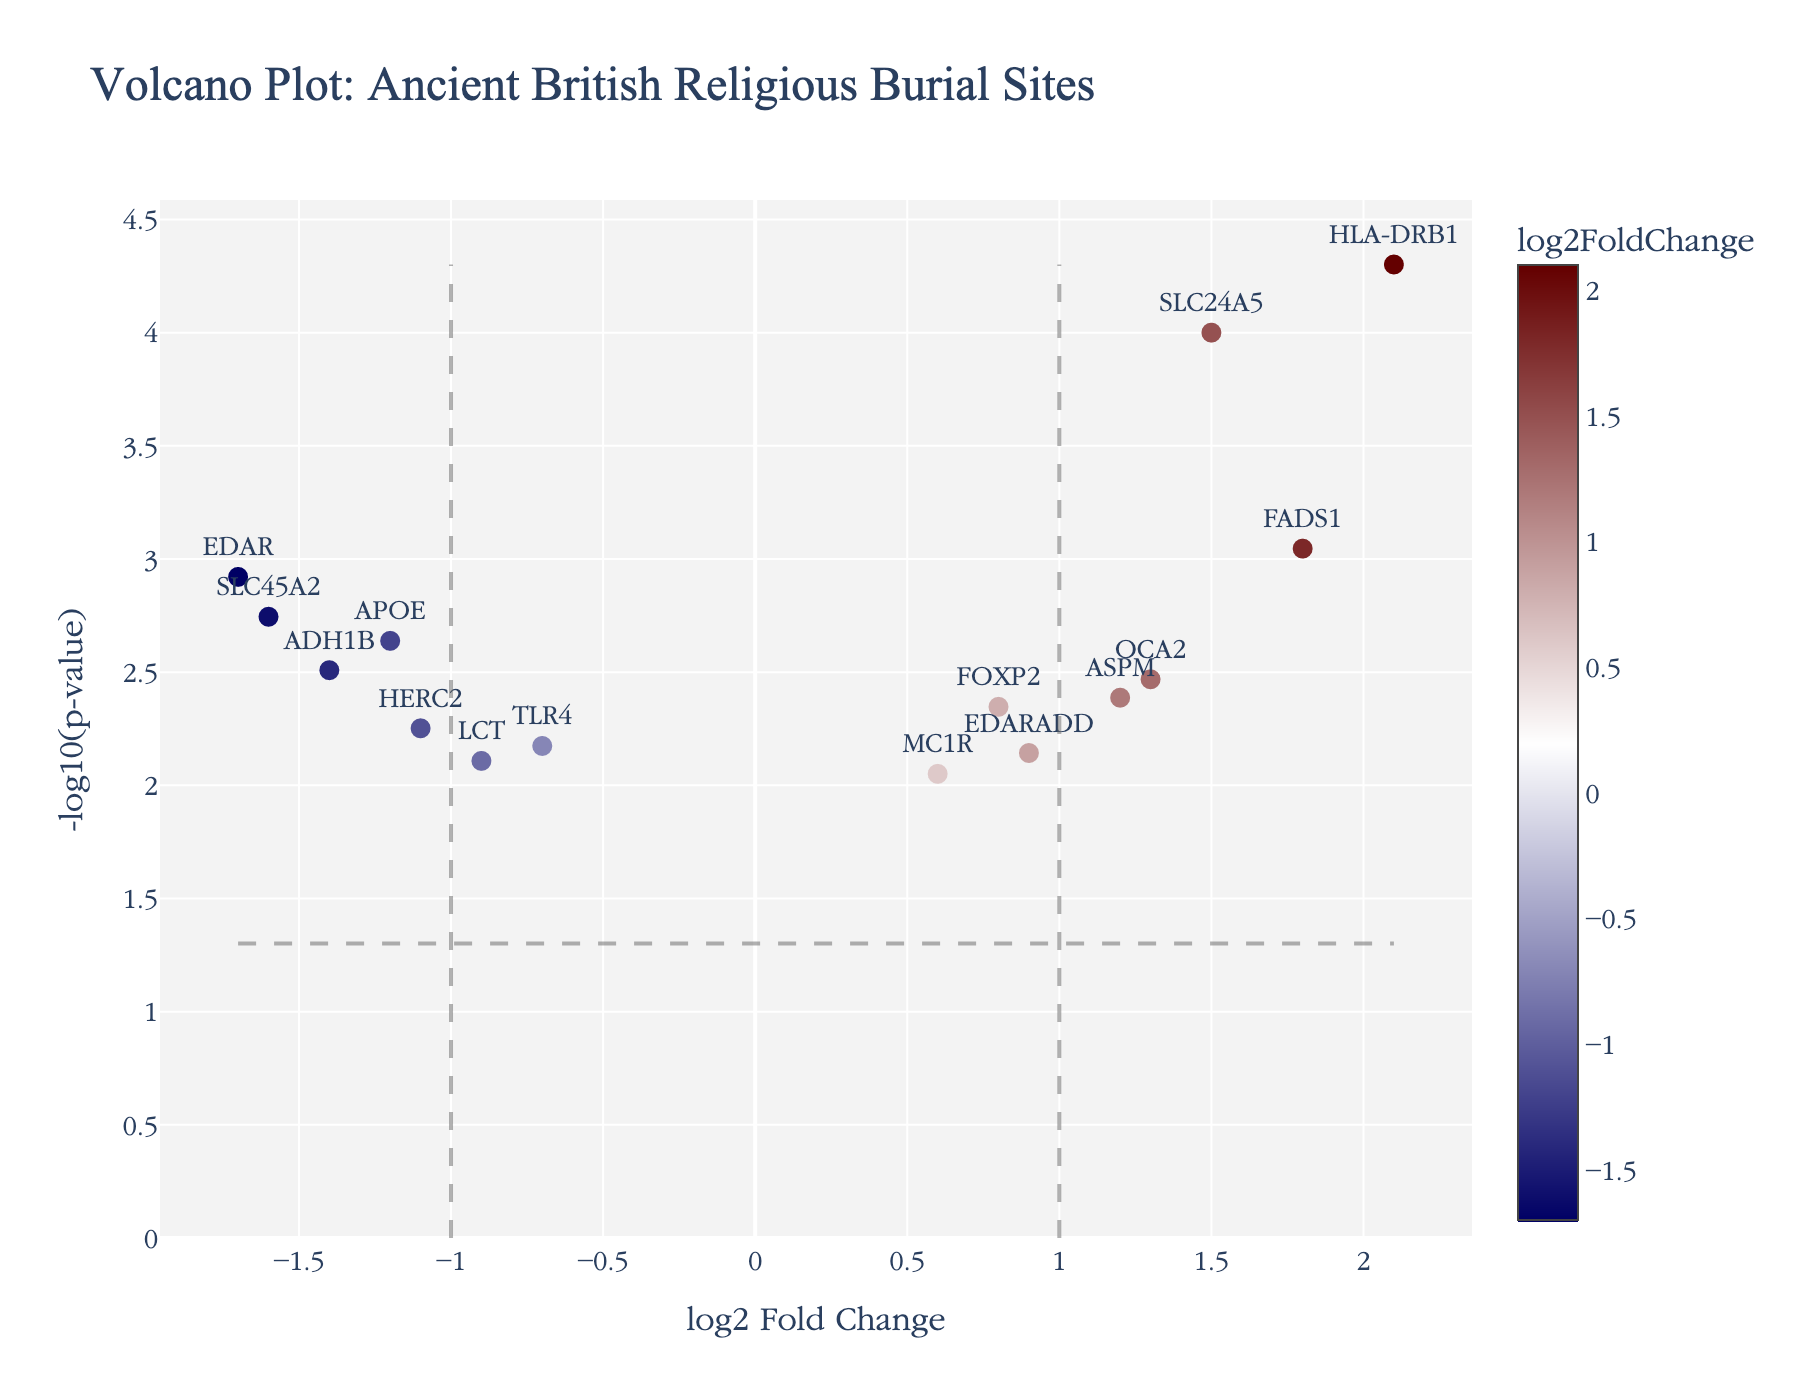What is the title of the volcano plot? The title is usually displayed at the top of the plot and gives an idea about what the plot represents. In this case, the title "Volcano Plot: Ancient British Religious Burial Sites" can be read directly from the plot.
Answer: Volcano Plot: Ancient British Religious Burial Sites Which gene has the highest log2 fold change? To determine the gene with the highest log2 fold change look for the point farthest to the right on the x-axis. In this plot, it is the gene HLA-DRB1 with a log2 fold change of 2.1.
Answer: HLA-DRB1 What is the significance threshold line set at for the p-value? The horizontal line on the plot represents the significance threshold, usually at -log10(0.05), which is about 1.3 on the y-axis.
Answer: -log10(0.05) Which genes are found above the significance threshold line? To answer this, look for genes placed above the horizontal threshold line at -log10(0.05). These genes include APOE, FOXP2, SLC24A5, HLA-DRB1, EDAR, OCA2, FADS1, ADH1B, SLC45A2, and ASPM.
Answer: APOE, FOXP2, SLC24A5, HLA-DRB1, EDAR, OCA2, FADS1, ADH1B, SLC45A2, ASPM Which gene has the lowest p-value and what is its log2 fold change? The gene with the lowest p-value will be the one positioned at the top of the plot. This gene is HLA-DRB1 with a log2 fold change of 2.1 and a p-value of 0.00005.
Answer: HLA-DRB1, log2 fold change is 2.1 Are there any genes with a log2 fold change less than -1 and significant p-value? Look for genes on the left of the vertical line at log2 fold change = -1 and which lie above the significance threshold line. These genes are APOE, EDAR, ADH1B, and SLC45A2.
Answer: APOE, EDAR, ADH1B, SLC45A2 Which genes have a log2 fold change greater than 1 and a p-value less than 0.001? This requires looking at genes to the right of the vertical line at log2 fold change = 1 and above the horizontal line denoting -log10(0.001). HLA-DRB1 and FADS1 meet these criteria.
Answer: HLA-DRB1, FADS1 How many genes have both a positive log2 fold change and are above the significance threshold? Count all genes on the right side (positive log2 fold change) and above the horizontal significance threshold line. There are six such genes: FOXP2, SLC24A5, HLA-DRB1, OCA2, FADS1, and ASPM.
Answer: Six Which gene's log2 fold change is closest to zero but still significant? Look for the gene closest to the vertical line at log2 fold change = 0 and above the significance threshold line. This gene is FOXP2 with a log2 fold change of 0.8.
Answer: FOXP2 